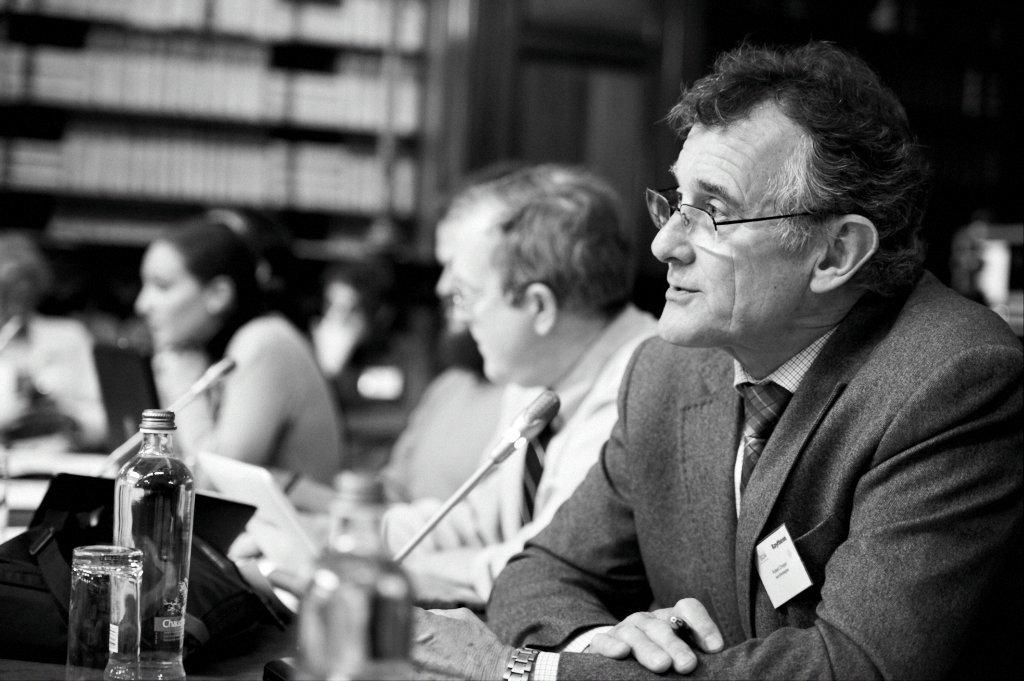What are the people in the image doing? There are persons sitting in the image. What object is present that might be used for amplifying sound? There is a microphone in the image. What type of container is visible in the image? There is a bottle in the image. What type of drinking vessel is present in the image? There is a glass in the image. What type of holiday is being celebrated in the image? There is no indication of a holiday being celebrated in the image. What topic is being discussed by the persons sitting in the image? The image does not provide information about the topic being discussed. 